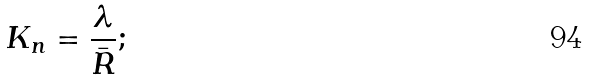<formula> <loc_0><loc_0><loc_500><loc_500>K _ { n } = \frac { \lambda } { \bar { R } } ;</formula> 